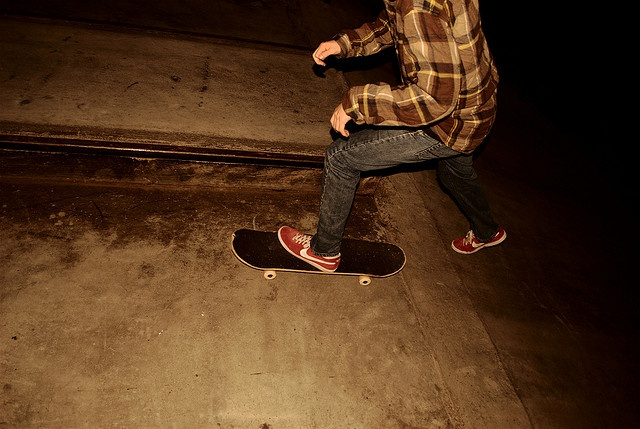Describe the objects in this image and their specific colors. I can see people in black, maroon, and brown tones and skateboard in black, maroon, tan, and brown tones in this image. 